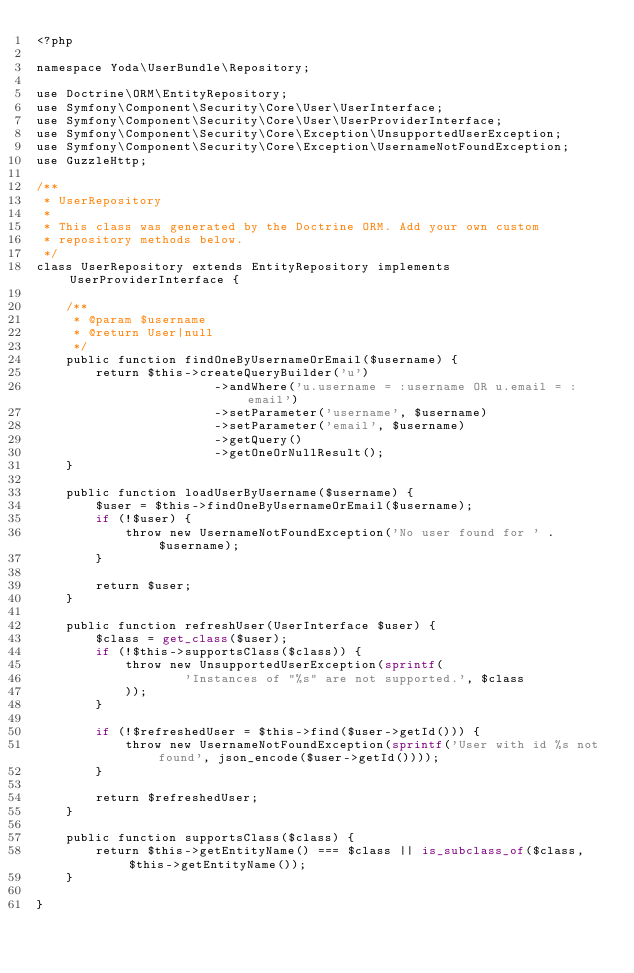Convert code to text. <code><loc_0><loc_0><loc_500><loc_500><_PHP_><?php

namespace Yoda\UserBundle\Repository;

use Doctrine\ORM\EntityRepository;
use Symfony\Component\Security\Core\User\UserInterface;
use Symfony\Component\Security\Core\User\UserProviderInterface;
use Symfony\Component\Security\Core\Exception\UnsupportedUserException;
use Symfony\Component\Security\Core\Exception\UsernameNotFoundException;
use GuzzleHttp;

/**
 * UserRepository
 *
 * This class was generated by the Doctrine ORM. Add your own custom
 * repository methods below.
 */
class UserRepository extends EntityRepository implements UserProviderInterface {

    /**
     * @param $username
     * @return User|null
     */
    public function findOneByUsernameOrEmail($username) {
        return $this->createQueryBuilder('u')
                        ->andWhere('u.username = :username OR u.email = :email')
                        ->setParameter('username', $username)
                        ->setParameter('email', $username)
                        ->getQuery()
                        ->getOneOrNullResult();
    }

    public function loadUserByUsername($username) {
        $user = $this->findOneByUsernameOrEmail($username);
        if (!$user) {
            throw new UsernameNotFoundException('No user found for ' . $username);
        }

        return $user;
    }

    public function refreshUser(UserInterface $user) {
        $class = get_class($user);
        if (!$this->supportsClass($class)) {
            throw new UnsupportedUserException(sprintf(
                    'Instances of "%s" are not supported.', $class
            ));
        }

        if (!$refreshedUser = $this->find($user->getId())) {
            throw new UsernameNotFoundException(sprintf('User with id %s not found', json_encode($user->getId())));
        }

        return $refreshedUser;
    }

    public function supportsClass($class) {
        return $this->getEntityName() === $class || is_subclass_of($class, $this->getEntityName());
    }

}
</code> 